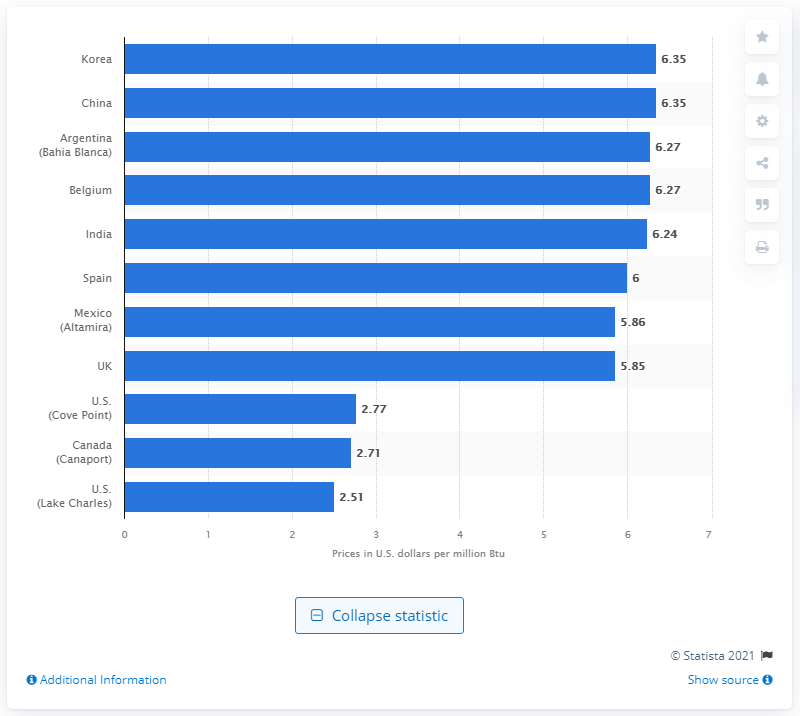Highlight a few significant elements in this photo. The landed price of liquefied natural gas in South Korea and China was 6.35. 